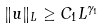<formula> <loc_0><loc_0><loc_500><loc_500>\| u \| _ { L } \geq C _ { 1 } L ^ { \gamma _ { 1 } }</formula> 